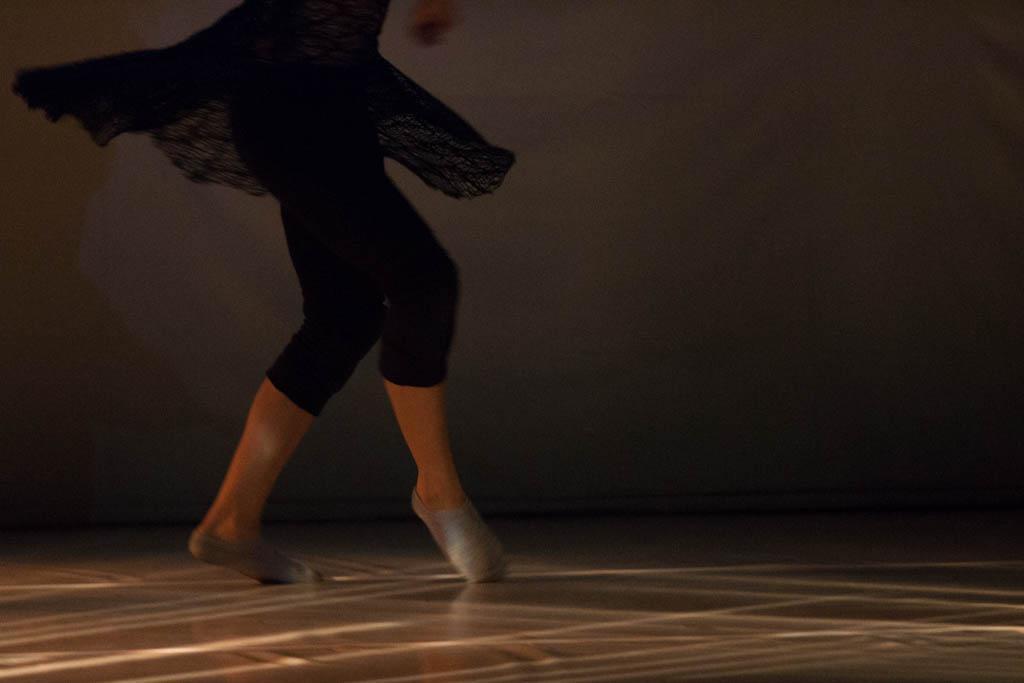Please provide a concise description of this image. In this picture we can see the woman legs, wearing black trouser and dancing on the floor. Behind there is a wall and dark background. 